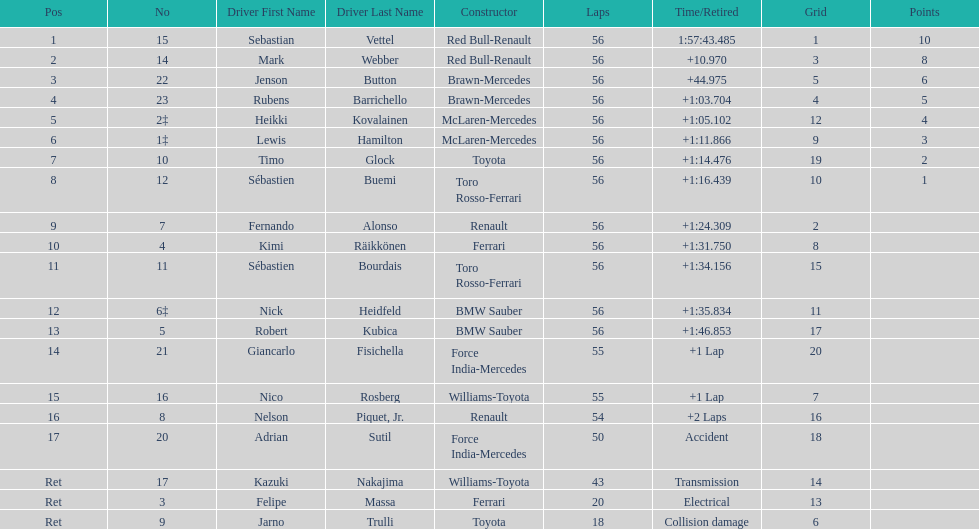Who was the slowest driver to finish the race? Robert Kubica. 